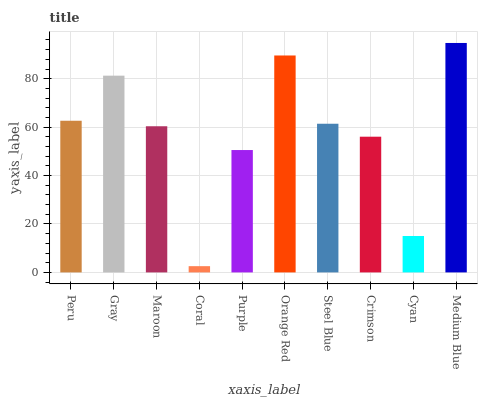Is Gray the minimum?
Answer yes or no. No. Is Gray the maximum?
Answer yes or no. No. Is Gray greater than Peru?
Answer yes or no. Yes. Is Peru less than Gray?
Answer yes or no. Yes. Is Peru greater than Gray?
Answer yes or no. No. Is Gray less than Peru?
Answer yes or no. No. Is Steel Blue the high median?
Answer yes or no. Yes. Is Maroon the low median?
Answer yes or no. Yes. Is Cyan the high median?
Answer yes or no. No. Is Cyan the low median?
Answer yes or no. No. 